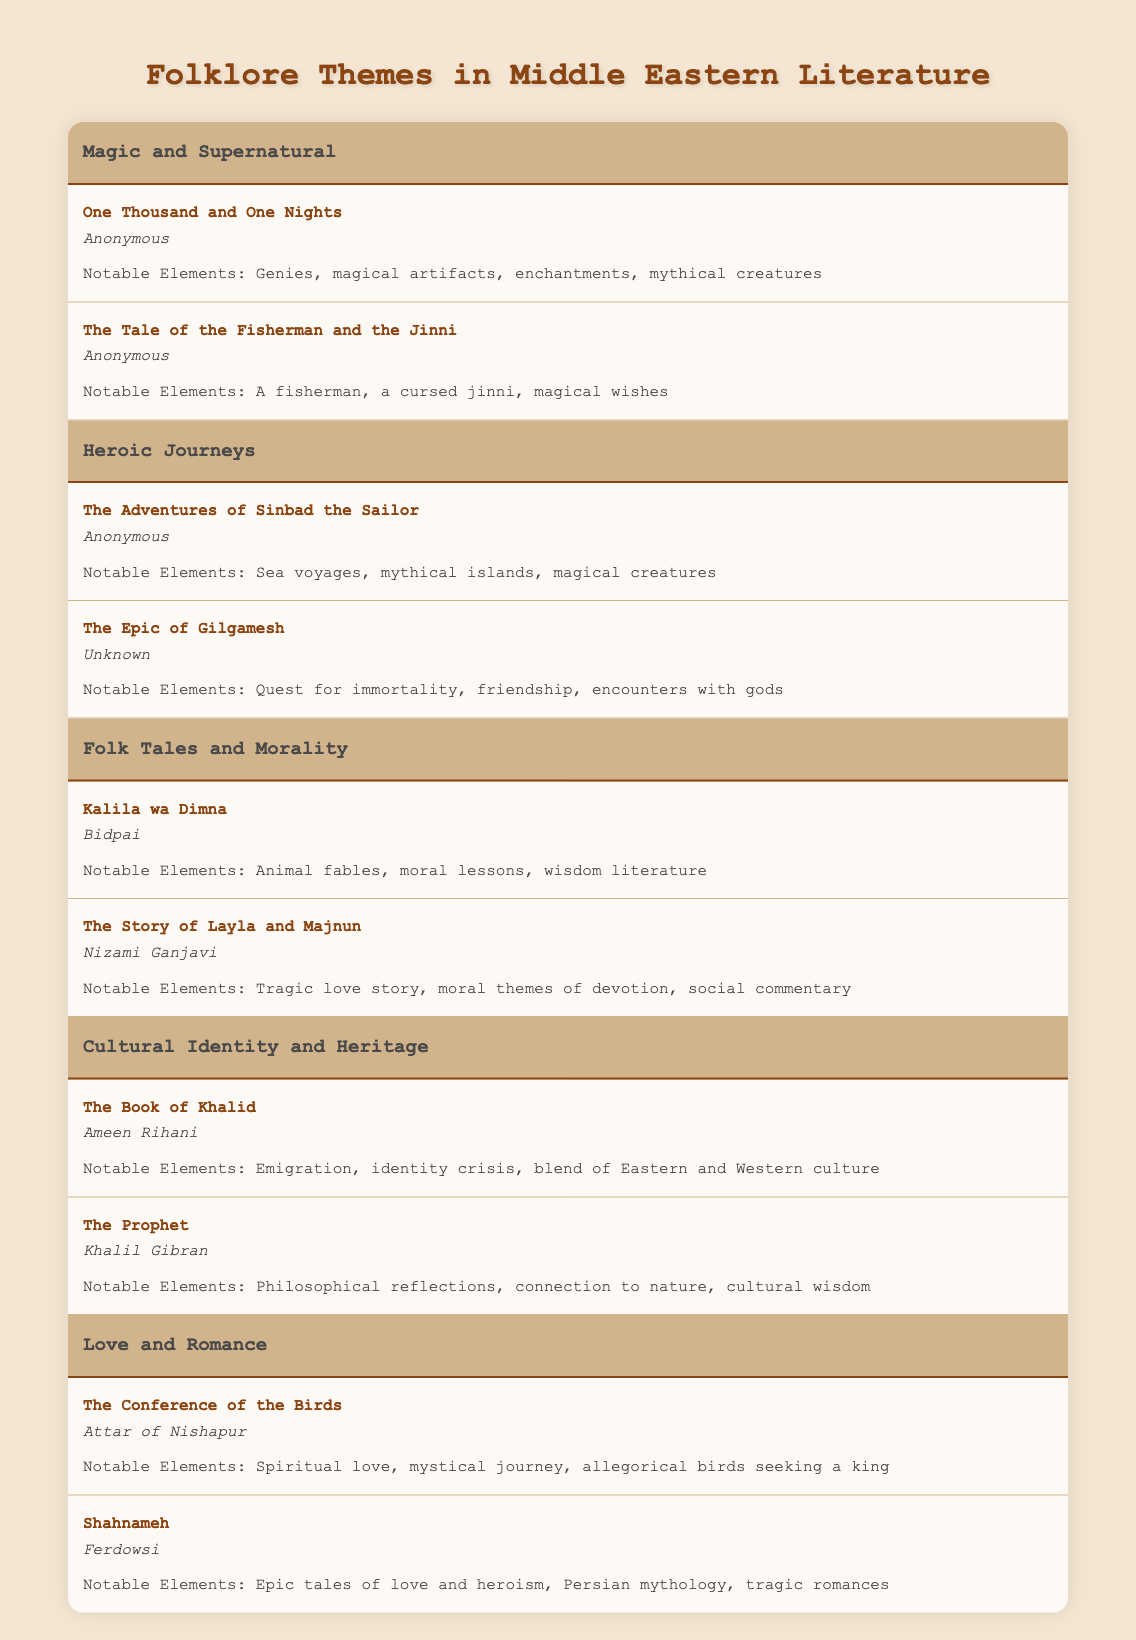What themes are present in this literature table? The table displays five themes: Magic and Supernatural, Heroic Journeys, Folk Tales and Morality, Cultural Identity and Heritage, and Love and Romance.
Answer: Five themes Which author wrote "The Story of Layla and Majnun"? According to the table, "The Story of Layla and Majnun" was written by Nizami Ganjavi.
Answer: Nizami Ganjavi How many examples are listed under the theme "Heroic Journeys"? There are two examples listed under "Heroic Journeys": "The Adventures of Sinbad the Sailor" and "The Epic of Gilgamesh".
Answer: Two examples Is "The Prophet" associated with Cultural Identity and Heritage? Yes, the table clearly associates "The Prophet" with the theme of Cultural Identity and Heritage.
Answer: Yes Which theme includes works that focus on moral lessons? The "Folk Tales and Morality" theme includes works that focus on moral lessons, such as "Kalila wa Dimna".
Answer: Folk Tales and Morality What notable elements are mentioned in "The Conference of the Birds"? The table indicates that notable elements in "The Conference of the Birds" include spiritual love, a mystical journey, and allegorical birds seeking a king.
Answer: Spiritual love, mystical journey, allegorical birds Which theme has the most diverse set of notable elements? "Magic and Supernatural" includes diverse notable elements like genies, magical artifacts, enchantments, and mythical creatures.
Answer: Magic and Supernatural If we count the total titles listed across all themes, how many are there? Summing all examples: 2 (Magic and Supernatural) + 2 (Heroic Journeys) + 2 (Folk Tales and Morality) + 2 (Cultural Identity and Heritage) + 2 (Love and Romance) gives a total of 10 titles.
Answer: 10 titles Is "The Epic of Gilgamesh" concerned with romantic themes? No, "The Epic of Gilgamesh" focuses on a quest for immortality and encounters with gods, not romantic themes.
Answer: No Which two works in the table explore themes of love and heroism? The two works that explore love and heroism are "The Conference of the Birds" and "Shahnameh".
Answer: "The Conference of the Birds" and "Shahnameh" Are there any works present in the table that deal with the concept of an identity crisis? Yes, "The Book of Khalid" addresses the theme of an identity crisis as part of Cultural Identity and Heritage.
Answer: Yes 